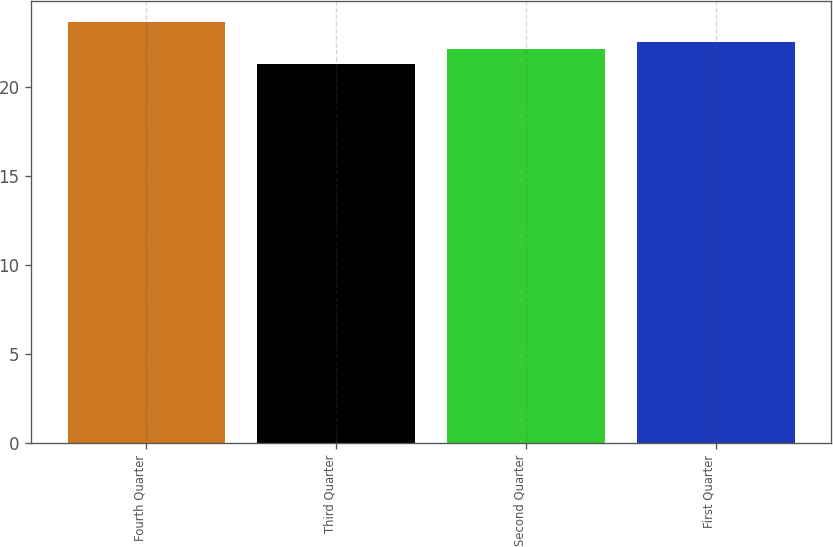Convert chart. <chart><loc_0><loc_0><loc_500><loc_500><bar_chart><fcel>Fourth Quarter<fcel>Third Quarter<fcel>Second Quarter<fcel>First Quarter<nl><fcel>23.65<fcel>21.3<fcel>22.14<fcel>22.51<nl></chart> 